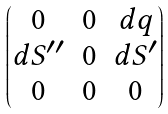<formula> <loc_0><loc_0><loc_500><loc_500>\begin{pmatrix} 0 & 0 & d q \\ d S ^ { \prime \prime } & 0 & d S ^ { \prime } \\ 0 & 0 & 0 \end{pmatrix}</formula> 